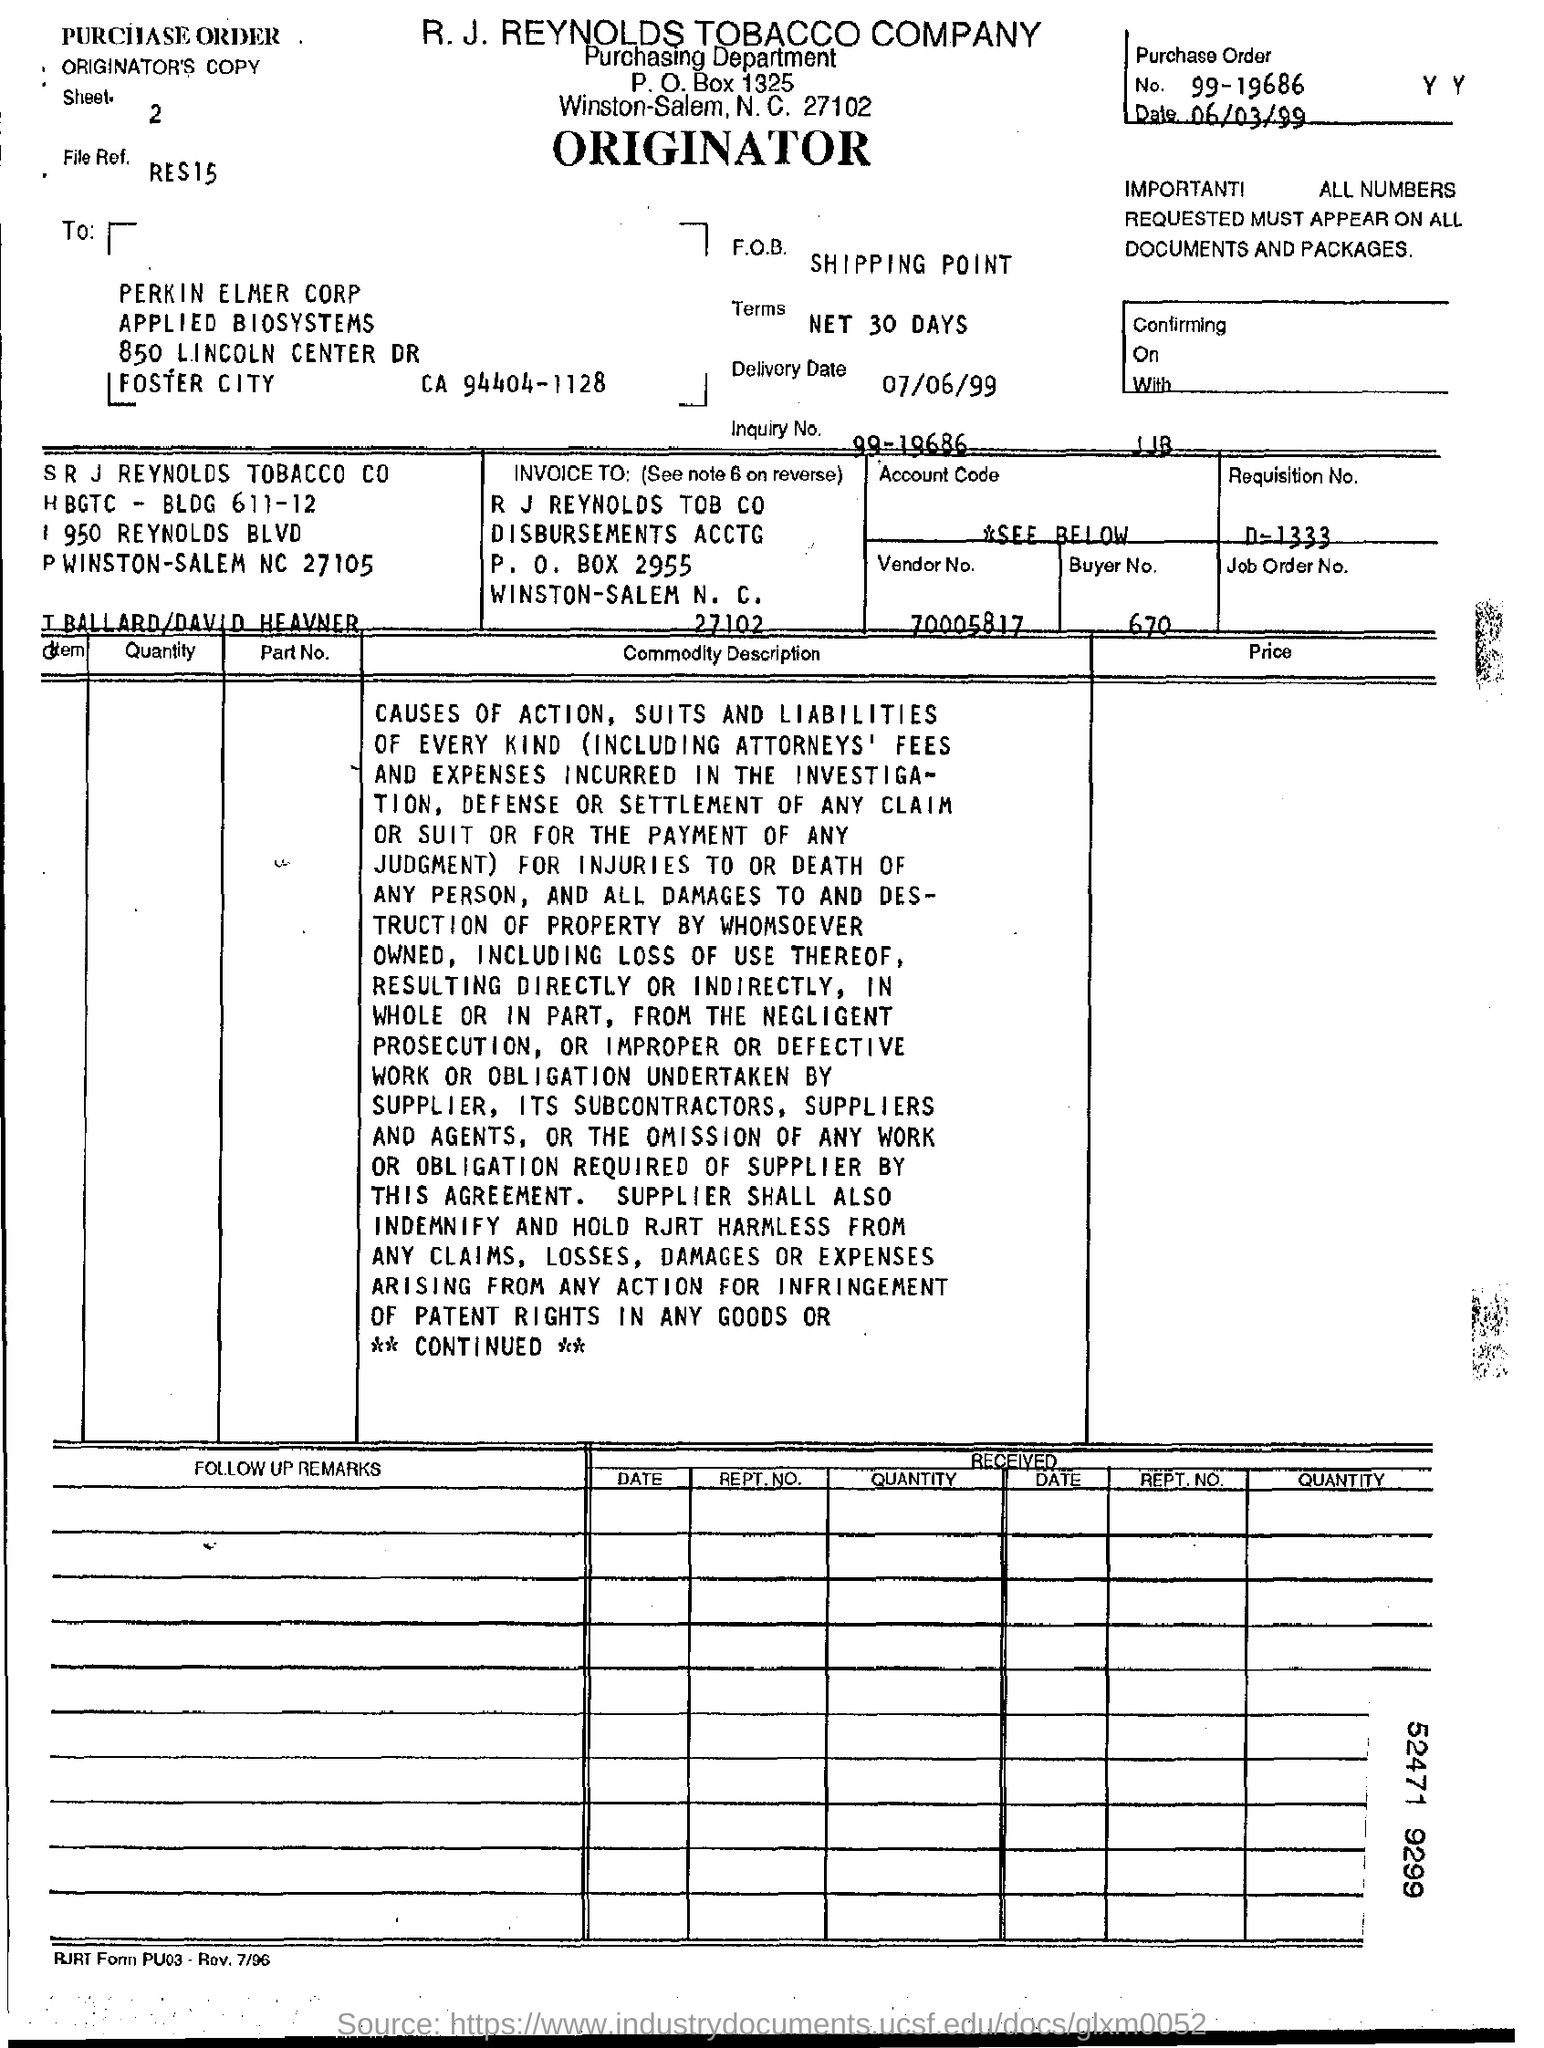List a handful of essential elements in this visual. The vendor number is 70005817... What is the purchase order number? 99-19686... The delivery date is July 6, 1999. The zipcode for R J Reynolds Tobacco Company is 27102. The P.O. box number of R.J. Reynolds Tobacco Company is 2955. 